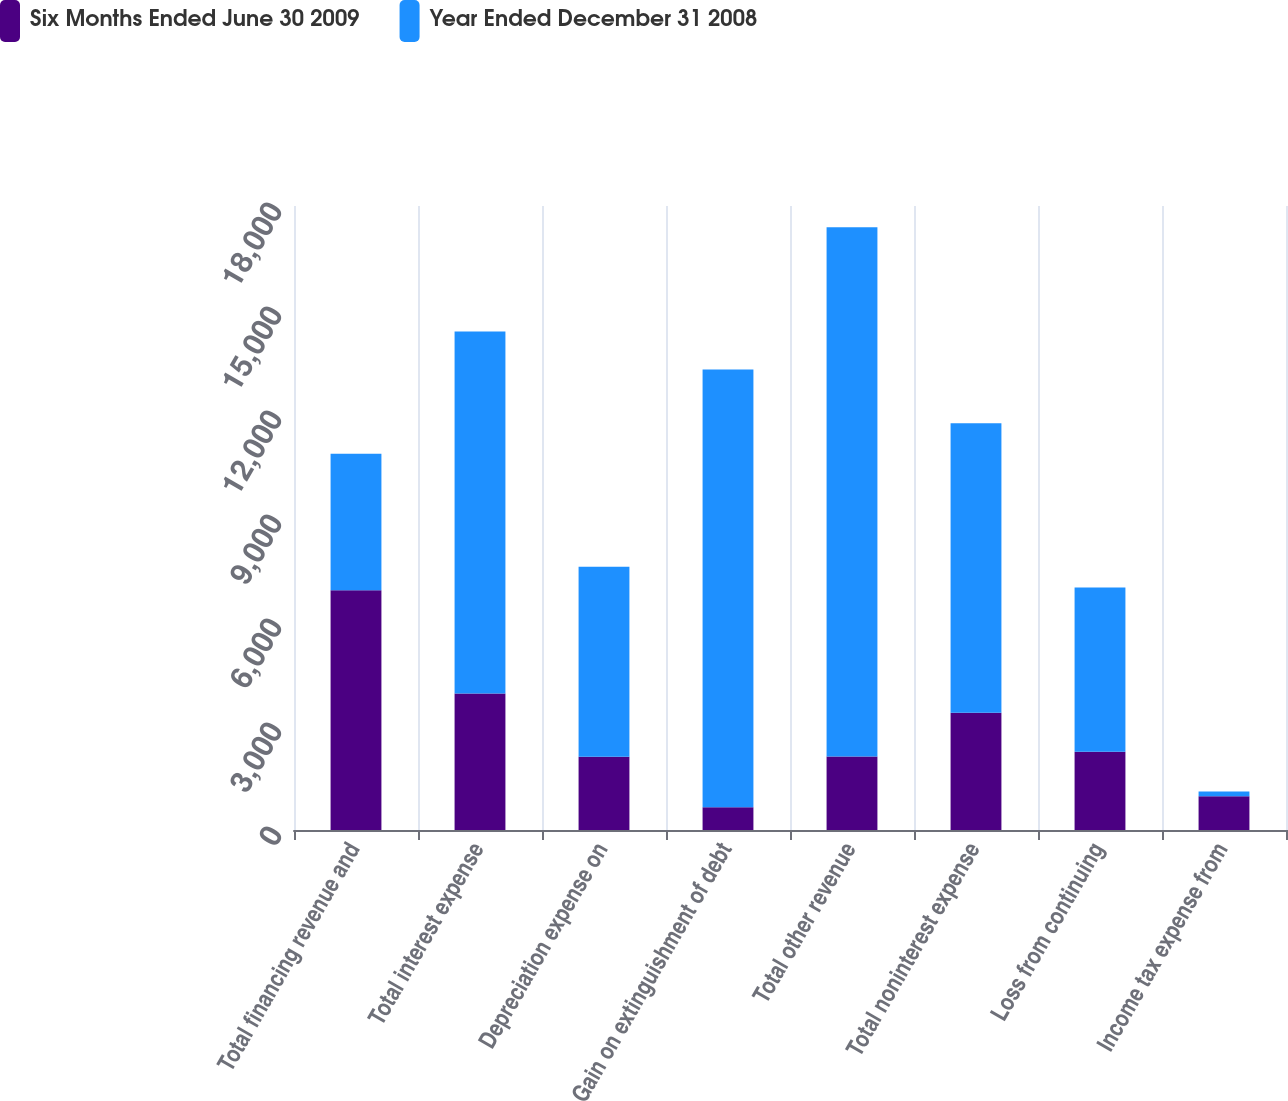Convert chart to OTSL. <chart><loc_0><loc_0><loc_500><loc_500><stacked_bar_chart><ecel><fcel>Total financing revenue and<fcel>Total interest expense<fcel>Depreciation expense on<fcel>Gain on extinguishment of debt<fcel>Total other revenue<fcel>Total noninterest expense<fcel>Loss from continuing<fcel>Income tax expense from<nl><fcel>Six Months Ended June 30 2009<fcel>6916<fcel>3936<fcel>2113<fcel>657<fcel>2117<fcel>3381<fcel>2260<fcel>972<nl><fcel>Year Ended December 31 2008<fcel>3936<fcel>10441<fcel>5478<fcel>12628<fcel>15271<fcel>8349<fcel>4737<fcel>136<nl></chart> 